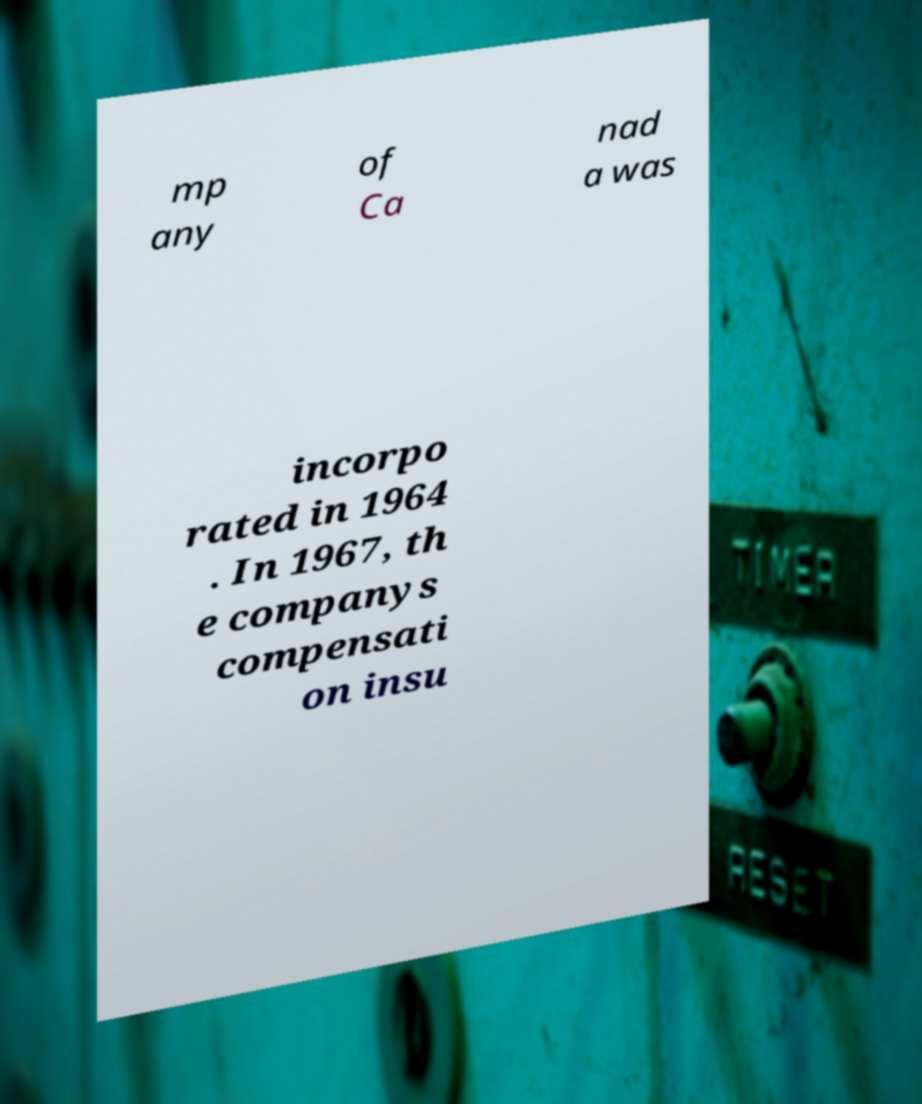Please read and relay the text visible in this image. What does it say? mp any of Ca nad a was incorpo rated in 1964 . In 1967, th e companys compensati on insu 